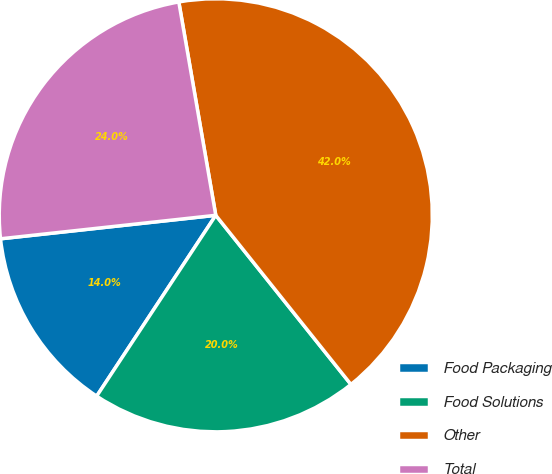Convert chart. <chart><loc_0><loc_0><loc_500><loc_500><pie_chart><fcel>Food Packaging<fcel>Food Solutions<fcel>Other<fcel>Total<nl><fcel>14.0%<fcel>20.0%<fcel>42.0%<fcel>24.0%<nl></chart> 